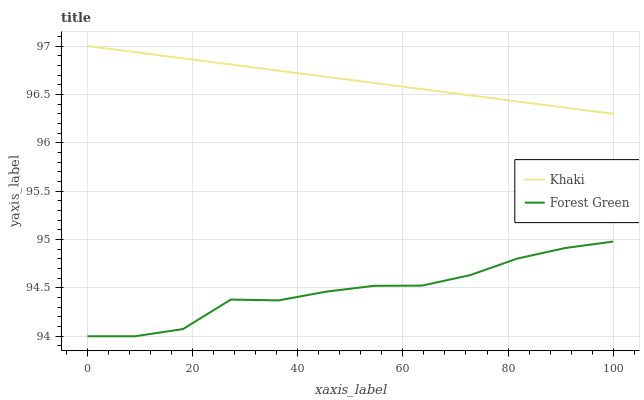Does Khaki have the minimum area under the curve?
Answer yes or no. No. Is Khaki the roughest?
Answer yes or no. No. Does Khaki have the lowest value?
Answer yes or no. No. Is Forest Green less than Khaki?
Answer yes or no. Yes. Is Khaki greater than Forest Green?
Answer yes or no. Yes. Does Forest Green intersect Khaki?
Answer yes or no. No. 